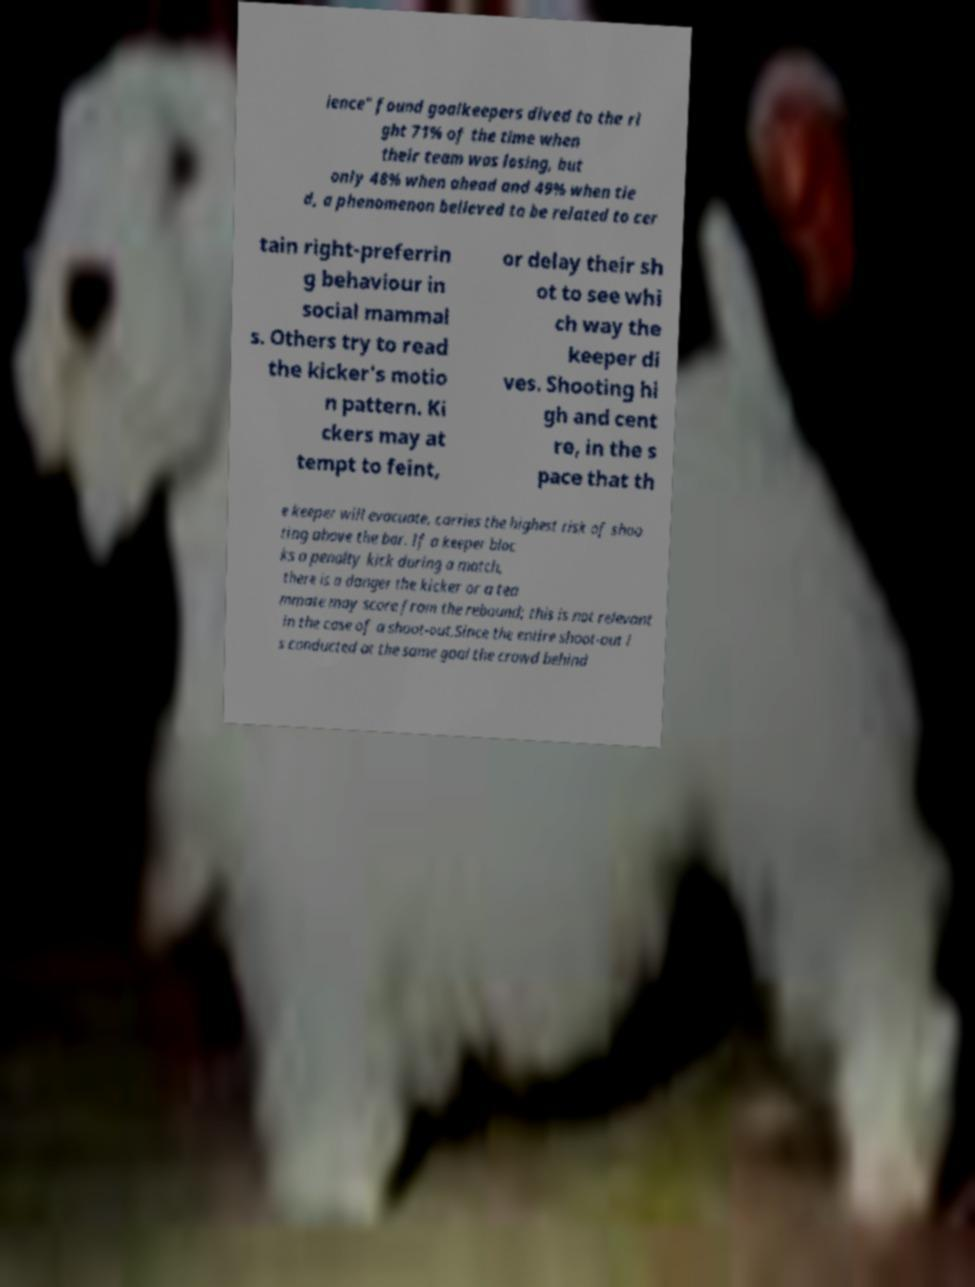For documentation purposes, I need the text within this image transcribed. Could you provide that? ience" found goalkeepers dived to the ri ght 71% of the time when their team was losing, but only 48% when ahead and 49% when tie d, a phenomenon believed to be related to cer tain right-preferrin g behaviour in social mammal s. Others try to read the kicker's motio n pattern. Ki ckers may at tempt to feint, or delay their sh ot to see whi ch way the keeper di ves. Shooting hi gh and cent re, in the s pace that th e keeper will evacuate, carries the highest risk of shoo ting above the bar. If a keeper bloc ks a penalty kick during a match, there is a danger the kicker or a tea mmate may score from the rebound; this is not relevant in the case of a shoot-out.Since the entire shoot-out i s conducted at the same goal the crowd behind 